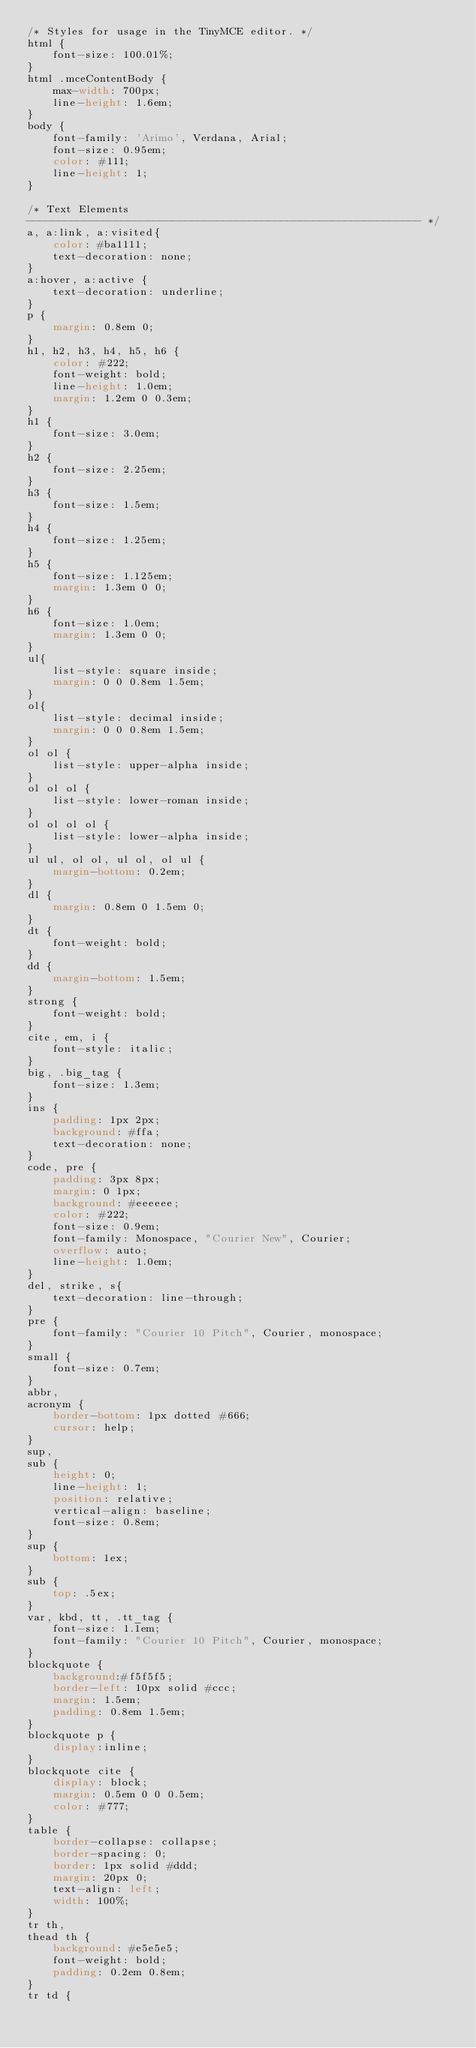<code> <loc_0><loc_0><loc_500><loc_500><_CSS_>/* Styles for usage in the TinyMCE editor. */
html {
	font-size: 100.01%;
}
html .mceContentBody {
	max-width: 700px;
	line-height: 1.6em;
}
body {
	font-family: 'Arimo', Verdana, Arial;
	font-size: 0.95em;
	color: #111;
	line-height: 1;
}

/* Text Elements
-------------------------------------------------------------- */
a, a:link, a:visited{
	color: #ba1111;
	text-decoration: none;
}
a:hover, a:active {
	text-decoration: underline;
}
p {
	margin: 0.8em 0;
}
h1, h2, h3, h4, h5, h6 {
	color: #222;
	font-weight: bold;
	line-height: 1.0em;
	margin: 1.2em 0 0.3em;
}
h1 {
	font-size: 3.0em;
}
h2 {
	font-size: 2.25em;
}
h3 {
	font-size: 1.5em;
}
h4 {
	font-size: 1.25em;
}
h5 {
	font-size: 1.125em;
	margin: 1.3em 0 0;
}
h6 {
	font-size: 1.0em;
	margin: 1.3em 0 0;
}
ul{
	list-style: square inside;
	margin: 0 0 0.8em 1.5em;
}
ol{
	list-style: decimal inside;
	margin: 0 0 0.8em 1.5em;
}
ol ol {
	list-style: upper-alpha inside;
}
ol ol ol {
	list-style: lower-roman inside;
}
ol ol ol ol {
	list-style: lower-alpha inside;
}
ul ul, ol ol, ul ol, ol ul {
	margin-bottom: 0.2em;
}
dl {
	margin: 0.8em 0 1.5em 0;
}
dt {
	font-weight: bold;
}
dd {
	margin-bottom: 1.5em;
}
strong {
	font-weight: bold;
}
cite, em, i {
	font-style: italic;
}
big, .big_tag {
	font-size: 1.3em;
}
ins {
	padding: 1px 2px;
	background: #ffa;
	text-decoration: none;
}
code, pre {
	padding: 3px 8px;
	margin: 0 1px;
	background: #eeeeee;
	color: #222;
	font-size: 0.9em;
	font-family: Monospace, "Courier New", Courier;
	overflow: auto;
	line-height: 1.0em;
}
del, strike, s{
	text-decoration: line-through;
}
pre {
	font-family: "Courier 10 Pitch", Courier, monospace;
}
small {
	font-size: 0.7em;
}
abbr,
acronym {
	border-bottom: 1px dotted #666;
	cursor: help;
}
sup,
sub {
	height: 0;
	line-height: 1;
	position: relative;
	vertical-align: baseline;
	font-size: 0.8em;
}
sup {
	bottom: 1ex;
}
sub {
	top: .5ex;
}
var, kbd, tt, .tt_tag {
	font-size: 1.1em;
	font-family: "Courier 10 Pitch", Courier, monospace;
}
blockquote {
	background:#f5f5f5;
	border-left: 10px solid #ccc;
	margin: 1.5em;
	padding: 0.8em 1.5em;
}
blockquote p {
	display:inline;
}
blockquote cite {
	display: block;
	margin: 0.5em 0 0 0.5em;
	color: #777;
}
table {
	border-collapse: collapse;
	border-spacing: 0;
	border: 1px solid #ddd;
	margin: 20px 0;
	text-align: left;
	width: 100%;
}
tr th,
thead th {
	background: #e5e5e5;
	font-weight: bold;
	padding: 0.2em 0.8em;
}
tr td {</code> 